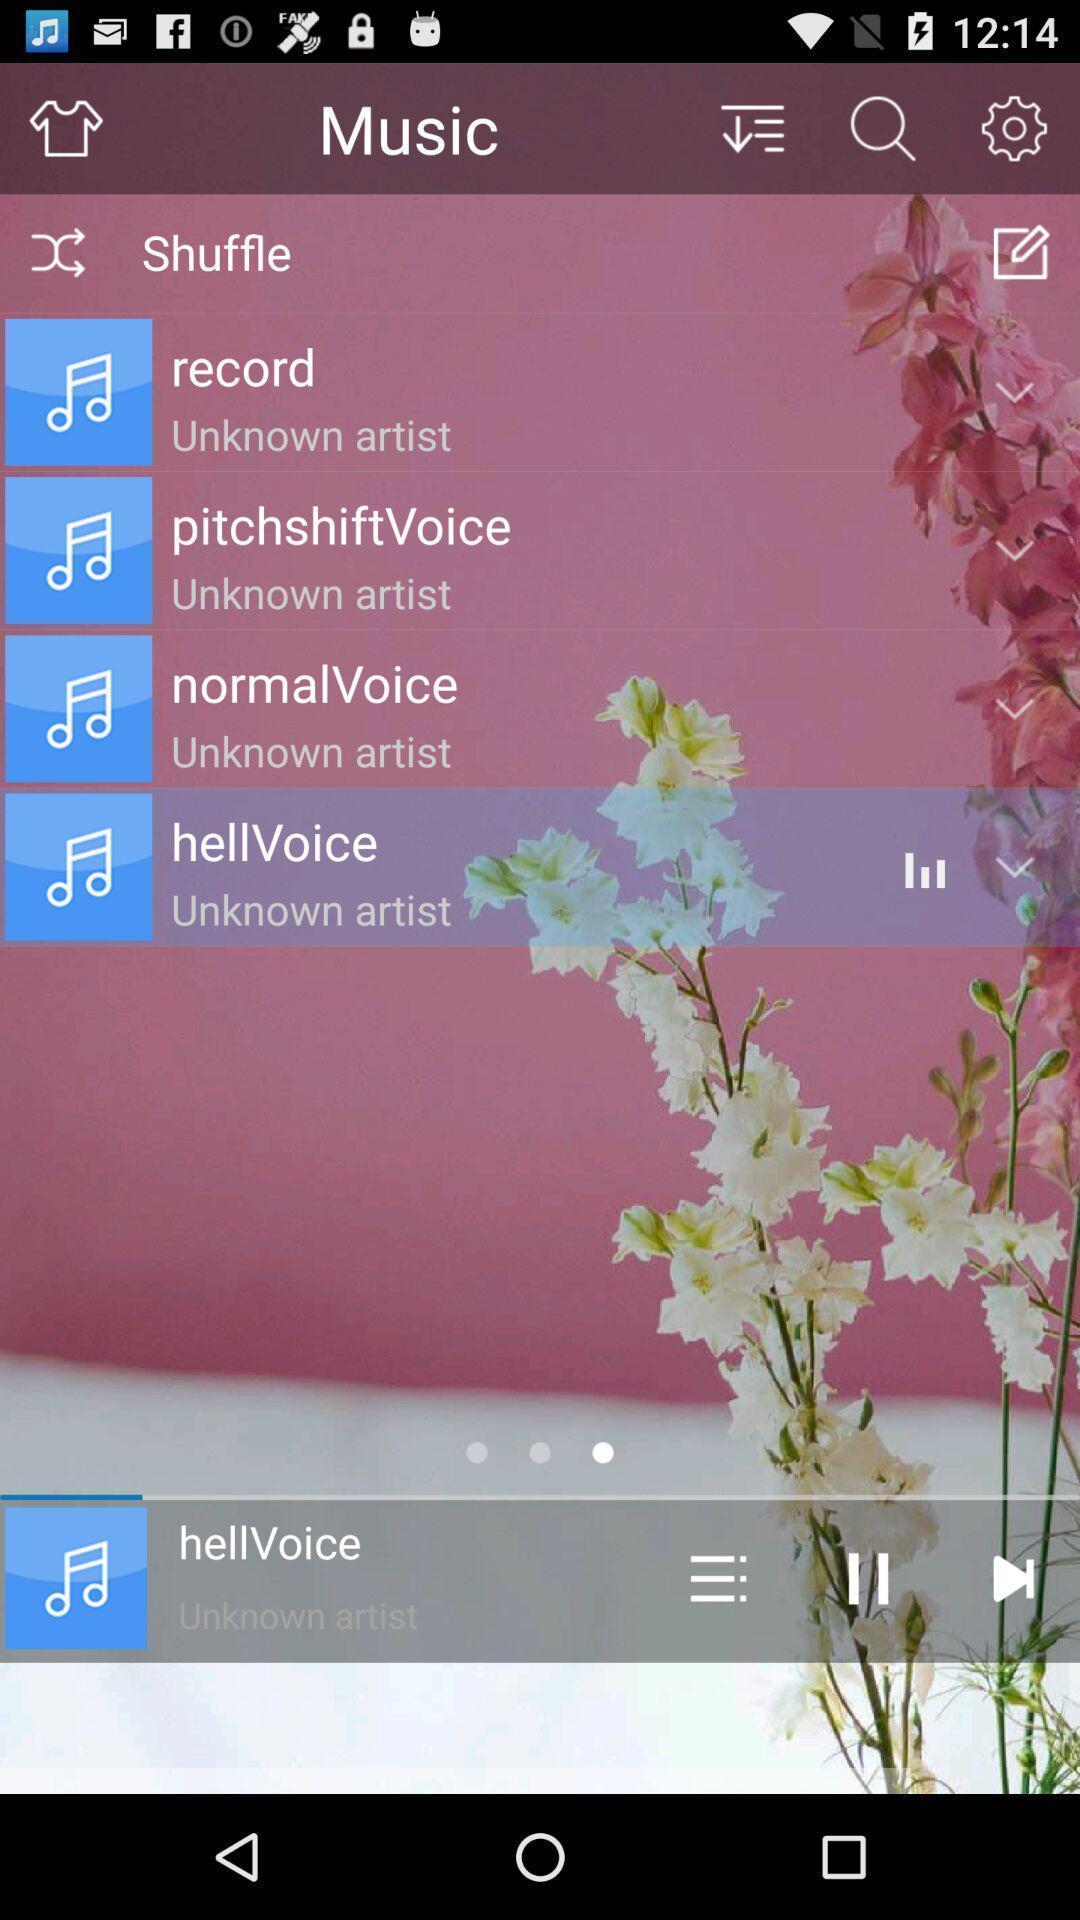Describe the content in this image. Page showing a list of music. 